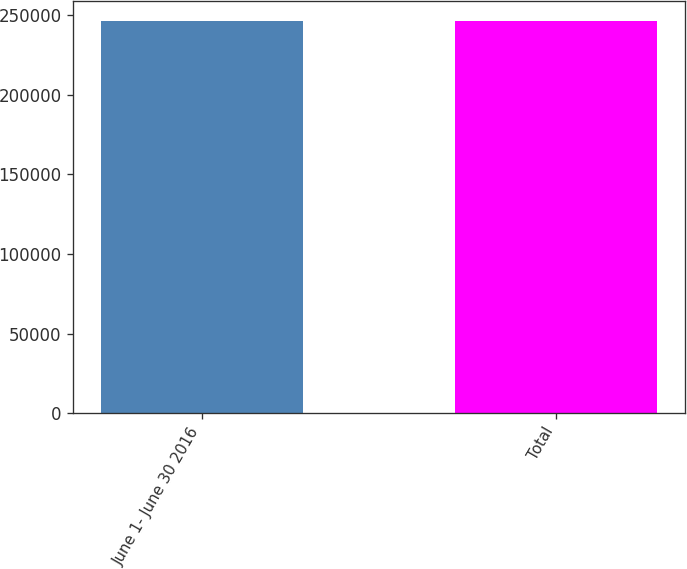Convert chart. <chart><loc_0><loc_0><loc_500><loc_500><bar_chart><fcel>June 1- June 30 2016<fcel>Total<nl><fcel>246400<fcel>246400<nl></chart> 